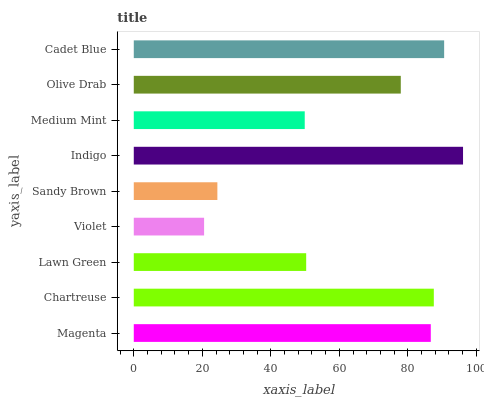Is Violet the minimum?
Answer yes or no. Yes. Is Indigo the maximum?
Answer yes or no. Yes. Is Chartreuse the minimum?
Answer yes or no. No. Is Chartreuse the maximum?
Answer yes or no. No. Is Chartreuse greater than Magenta?
Answer yes or no. Yes. Is Magenta less than Chartreuse?
Answer yes or no. Yes. Is Magenta greater than Chartreuse?
Answer yes or no. No. Is Chartreuse less than Magenta?
Answer yes or no. No. Is Olive Drab the high median?
Answer yes or no. Yes. Is Olive Drab the low median?
Answer yes or no. Yes. Is Violet the high median?
Answer yes or no. No. Is Sandy Brown the low median?
Answer yes or no. No. 